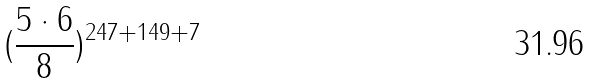<formula> <loc_0><loc_0><loc_500><loc_500>( \frac { 5 \cdot 6 } { 8 } ) ^ { 2 4 7 + 1 4 9 + 7 }</formula> 